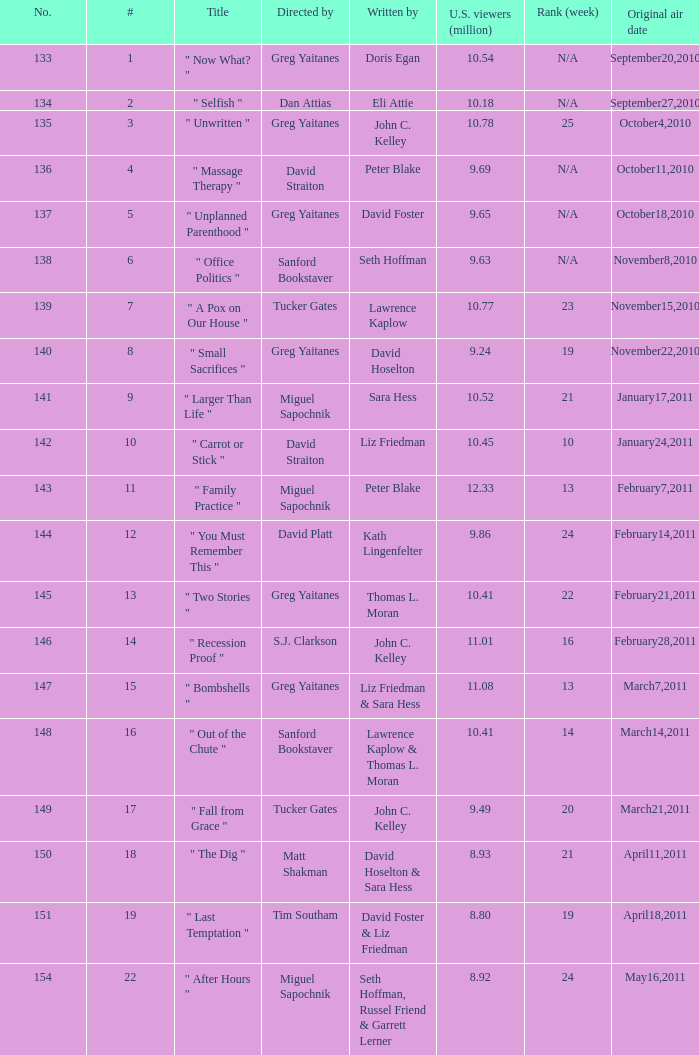Where did the episode rank that was written by thomas l. moran? 22.0. 